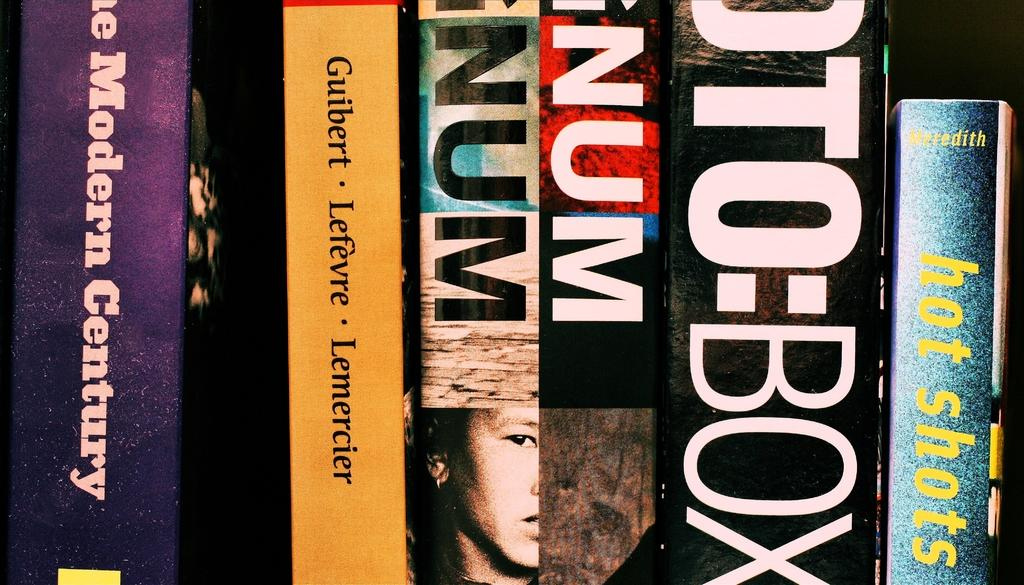<image>
Share a concise interpretation of the image provided. A series of books on a shelf with one titled Hot Shots. 